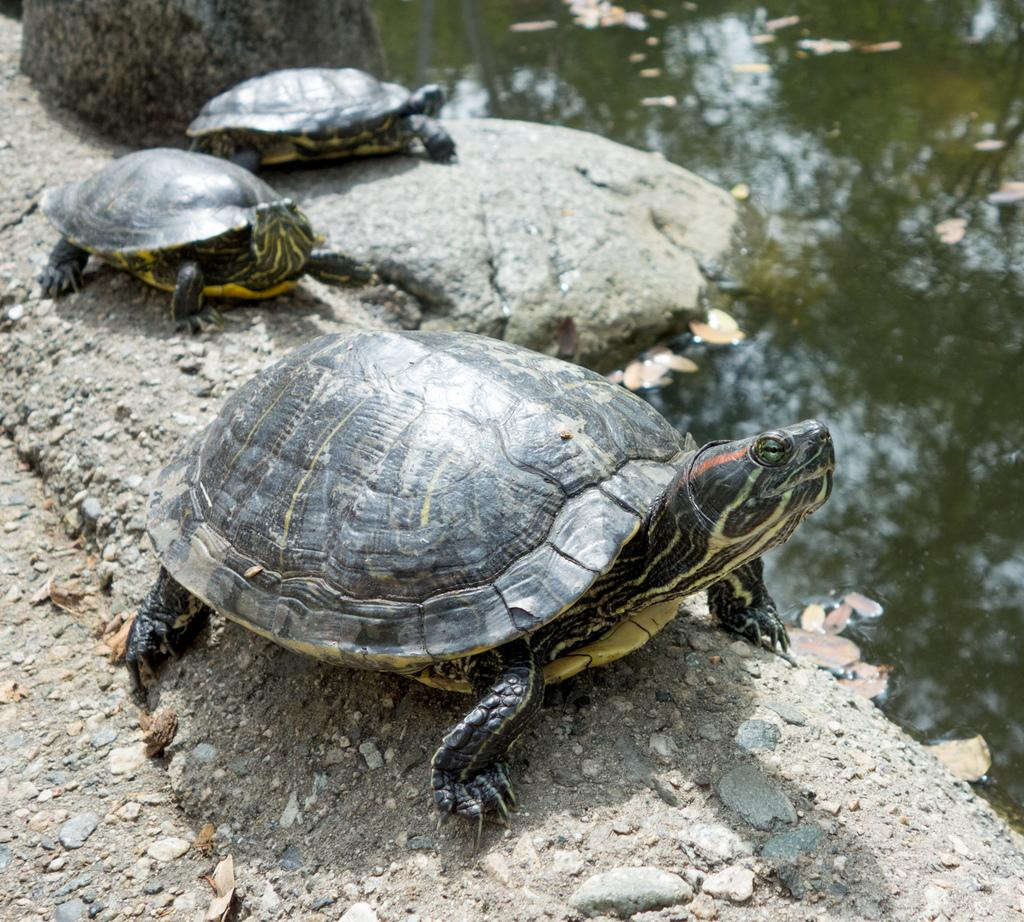What type of animals are in the image? There are tortoises in the image. Where are the tortoises located? The tortoises are on stones in the image. What else can be seen in the water in the image? There are dried leaves on the water in the image. Is water visible in the image? Yes, the water is visible in the image. What type of corn is growing in the image? There is no corn present in the image; it features tortoises on stones with dried leaves on the water. 